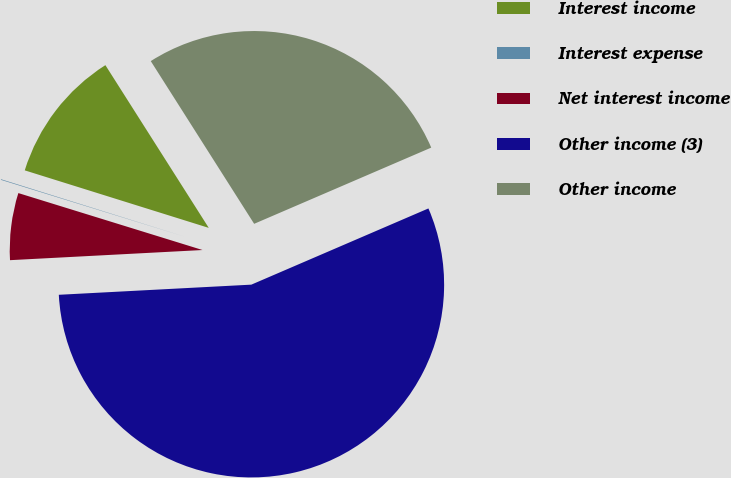Convert chart. <chart><loc_0><loc_0><loc_500><loc_500><pie_chart><fcel>Interest income<fcel>Interest expense<fcel>Net interest income<fcel>Other income (3)<fcel>Other income<nl><fcel>11.17%<fcel>0.05%<fcel>5.61%<fcel>55.63%<fcel>27.54%<nl></chart> 